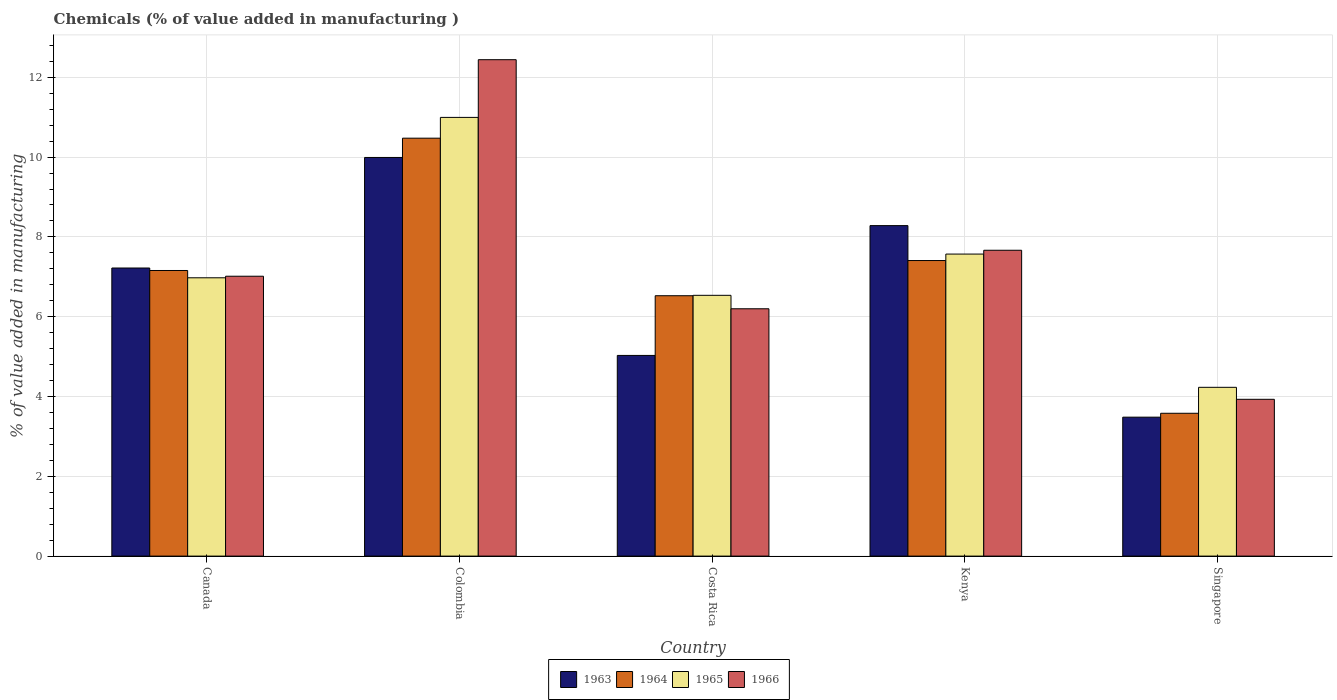How many groups of bars are there?
Make the answer very short. 5. Are the number of bars per tick equal to the number of legend labels?
Provide a succinct answer. Yes. Are the number of bars on each tick of the X-axis equal?
Your response must be concise. Yes. How many bars are there on the 5th tick from the right?
Your answer should be compact. 4. In how many cases, is the number of bars for a given country not equal to the number of legend labels?
Your response must be concise. 0. What is the value added in manufacturing chemicals in 1963 in Canada?
Your answer should be very brief. 7.22. Across all countries, what is the maximum value added in manufacturing chemicals in 1964?
Offer a very short reply. 10.47. Across all countries, what is the minimum value added in manufacturing chemicals in 1965?
Your answer should be compact. 4.23. In which country was the value added in manufacturing chemicals in 1964 minimum?
Your response must be concise. Singapore. What is the total value added in manufacturing chemicals in 1965 in the graph?
Provide a succinct answer. 36.31. What is the difference between the value added in manufacturing chemicals in 1965 in Colombia and that in Costa Rica?
Your answer should be very brief. 4.46. What is the difference between the value added in manufacturing chemicals in 1964 in Canada and the value added in manufacturing chemicals in 1963 in Colombia?
Provide a succinct answer. -2.83. What is the average value added in manufacturing chemicals in 1963 per country?
Provide a short and direct response. 6.8. What is the difference between the value added in manufacturing chemicals of/in 1964 and value added in manufacturing chemicals of/in 1963 in Costa Rica?
Make the answer very short. 1.5. In how many countries, is the value added in manufacturing chemicals in 1965 greater than 7.2 %?
Offer a terse response. 2. What is the ratio of the value added in manufacturing chemicals in 1966 in Canada to that in Kenya?
Your response must be concise. 0.92. Is the difference between the value added in manufacturing chemicals in 1964 in Colombia and Singapore greater than the difference between the value added in manufacturing chemicals in 1963 in Colombia and Singapore?
Make the answer very short. Yes. What is the difference between the highest and the second highest value added in manufacturing chemicals in 1966?
Your response must be concise. -5.43. What is the difference between the highest and the lowest value added in manufacturing chemicals in 1963?
Your answer should be very brief. 6.51. Is the sum of the value added in manufacturing chemicals in 1965 in Canada and Singapore greater than the maximum value added in manufacturing chemicals in 1963 across all countries?
Offer a very short reply. Yes. Is it the case that in every country, the sum of the value added in manufacturing chemicals in 1964 and value added in manufacturing chemicals in 1963 is greater than the sum of value added in manufacturing chemicals in 1965 and value added in manufacturing chemicals in 1966?
Give a very brief answer. No. What does the 4th bar from the left in Kenya represents?
Your response must be concise. 1966. What does the 1st bar from the right in Kenya represents?
Make the answer very short. 1966. Are all the bars in the graph horizontal?
Provide a succinct answer. No. How many countries are there in the graph?
Offer a terse response. 5. What is the difference between two consecutive major ticks on the Y-axis?
Make the answer very short. 2. Are the values on the major ticks of Y-axis written in scientific E-notation?
Make the answer very short. No. Where does the legend appear in the graph?
Ensure brevity in your answer.  Bottom center. How are the legend labels stacked?
Make the answer very short. Horizontal. What is the title of the graph?
Offer a terse response. Chemicals (% of value added in manufacturing ). What is the label or title of the X-axis?
Keep it short and to the point. Country. What is the label or title of the Y-axis?
Ensure brevity in your answer.  % of value added in manufacturing. What is the % of value added in manufacturing of 1963 in Canada?
Ensure brevity in your answer.  7.22. What is the % of value added in manufacturing in 1964 in Canada?
Your response must be concise. 7.16. What is the % of value added in manufacturing of 1965 in Canada?
Provide a short and direct response. 6.98. What is the % of value added in manufacturing in 1966 in Canada?
Provide a succinct answer. 7.01. What is the % of value added in manufacturing of 1963 in Colombia?
Your response must be concise. 9.99. What is the % of value added in manufacturing of 1964 in Colombia?
Make the answer very short. 10.47. What is the % of value added in manufacturing of 1965 in Colombia?
Make the answer very short. 10.99. What is the % of value added in manufacturing in 1966 in Colombia?
Provide a short and direct response. 12.44. What is the % of value added in manufacturing in 1963 in Costa Rica?
Your answer should be very brief. 5.03. What is the % of value added in manufacturing of 1964 in Costa Rica?
Your response must be concise. 6.53. What is the % of value added in manufacturing of 1965 in Costa Rica?
Your answer should be very brief. 6.54. What is the % of value added in manufacturing in 1966 in Costa Rica?
Offer a terse response. 6.2. What is the % of value added in manufacturing in 1963 in Kenya?
Offer a terse response. 8.28. What is the % of value added in manufacturing of 1964 in Kenya?
Your response must be concise. 7.41. What is the % of value added in manufacturing of 1965 in Kenya?
Provide a short and direct response. 7.57. What is the % of value added in manufacturing of 1966 in Kenya?
Provide a short and direct response. 7.67. What is the % of value added in manufacturing in 1963 in Singapore?
Provide a short and direct response. 3.48. What is the % of value added in manufacturing of 1964 in Singapore?
Offer a very short reply. 3.58. What is the % of value added in manufacturing in 1965 in Singapore?
Make the answer very short. 4.23. What is the % of value added in manufacturing of 1966 in Singapore?
Your answer should be compact. 3.93. Across all countries, what is the maximum % of value added in manufacturing in 1963?
Keep it short and to the point. 9.99. Across all countries, what is the maximum % of value added in manufacturing of 1964?
Make the answer very short. 10.47. Across all countries, what is the maximum % of value added in manufacturing of 1965?
Make the answer very short. 10.99. Across all countries, what is the maximum % of value added in manufacturing in 1966?
Offer a very short reply. 12.44. Across all countries, what is the minimum % of value added in manufacturing in 1963?
Provide a short and direct response. 3.48. Across all countries, what is the minimum % of value added in manufacturing in 1964?
Keep it short and to the point. 3.58. Across all countries, what is the minimum % of value added in manufacturing of 1965?
Your response must be concise. 4.23. Across all countries, what is the minimum % of value added in manufacturing of 1966?
Ensure brevity in your answer.  3.93. What is the total % of value added in manufacturing in 1963 in the graph?
Your answer should be very brief. 34.01. What is the total % of value added in manufacturing of 1964 in the graph?
Offer a very short reply. 35.15. What is the total % of value added in manufacturing in 1965 in the graph?
Your response must be concise. 36.31. What is the total % of value added in manufacturing of 1966 in the graph?
Your response must be concise. 37.25. What is the difference between the % of value added in manufacturing of 1963 in Canada and that in Colombia?
Offer a very short reply. -2.77. What is the difference between the % of value added in manufacturing of 1964 in Canada and that in Colombia?
Offer a terse response. -3.32. What is the difference between the % of value added in manufacturing of 1965 in Canada and that in Colombia?
Keep it short and to the point. -4.02. What is the difference between the % of value added in manufacturing of 1966 in Canada and that in Colombia?
Give a very brief answer. -5.43. What is the difference between the % of value added in manufacturing of 1963 in Canada and that in Costa Rica?
Give a very brief answer. 2.19. What is the difference between the % of value added in manufacturing in 1964 in Canada and that in Costa Rica?
Your response must be concise. 0.63. What is the difference between the % of value added in manufacturing in 1965 in Canada and that in Costa Rica?
Your response must be concise. 0.44. What is the difference between the % of value added in manufacturing of 1966 in Canada and that in Costa Rica?
Give a very brief answer. 0.82. What is the difference between the % of value added in manufacturing of 1963 in Canada and that in Kenya?
Your response must be concise. -1.06. What is the difference between the % of value added in manufacturing in 1964 in Canada and that in Kenya?
Your answer should be very brief. -0.25. What is the difference between the % of value added in manufacturing of 1965 in Canada and that in Kenya?
Your answer should be very brief. -0.59. What is the difference between the % of value added in manufacturing in 1966 in Canada and that in Kenya?
Provide a succinct answer. -0.65. What is the difference between the % of value added in manufacturing in 1963 in Canada and that in Singapore?
Your answer should be compact. 3.74. What is the difference between the % of value added in manufacturing of 1964 in Canada and that in Singapore?
Keep it short and to the point. 3.58. What is the difference between the % of value added in manufacturing in 1965 in Canada and that in Singapore?
Your answer should be very brief. 2.75. What is the difference between the % of value added in manufacturing of 1966 in Canada and that in Singapore?
Provide a short and direct response. 3.08. What is the difference between the % of value added in manufacturing in 1963 in Colombia and that in Costa Rica?
Keep it short and to the point. 4.96. What is the difference between the % of value added in manufacturing of 1964 in Colombia and that in Costa Rica?
Your response must be concise. 3.95. What is the difference between the % of value added in manufacturing in 1965 in Colombia and that in Costa Rica?
Your response must be concise. 4.46. What is the difference between the % of value added in manufacturing of 1966 in Colombia and that in Costa Rica?
Provide a short and direct response. 6.24. What is the difference between the % of value added in manufacturing of 1963 in Colombia and that in Kenya?
Your response must be concise. 1.71. What is the difference between the % of value added in manufacturing in 1964 in Colombia and that in Kenya?
Provide a succinct answer. 3.07. What is the difference between the % of value added in manufacturing of 1965 in Colombia and that in Kenya?
Ensure brevity in your answer.  3.43. What is the difference between the % of value added in manufacturing of 1966 in Colombia and that in Kenya?
Make the answer very short. 4.78. What is the difference between the % of value added in manufacturing in 1963 in Colombia and that in Singapore?
Give a very brief answer. 6.51. What is the difference between the % of value added in manufacturing of 1964 in Colombia and that in Singapore?
Offer a very short reply. 6.89. What is the difference between the % of value added in manufacturing in 1965 in Colombia and that in Singapore?
Keep it short and to the point. 6.76. What is the difference between the % of value added in manufacturing in 1966 in Colombia and that in Singapore?
Offer a very short reply. 8.51. What is the difference between the % of value added in manufacturing of 1963 in Costa Rica and that in Kenya?
Your answer should be very brief. -3.25. What is the difference between the % of value added in manufacturing of 1964 in Costa Rica and that in Kenya?
Your answer should be very brief. -0.88. What is the difference between the % of value added in manufacturing in 1965 in Costa Rica and that in Kenya?
Ensure brevity in your answer.  -1.03. What is the difference between the % of value added in manufacturing in 1966 in Costa Rica and that in Kenya?
Your answer should be very brief. -1.47. What is the difference between the % of value added in manufacturing in 1963 in Costa Rica and that in Singapore?
Provide a succinct answer. 1.55. What is the difference between the % of value added in manufacturing in 1964 in Costa Rica and that in Singapore?
Provide a short and direct response. 2.95. What is the difference between the % of value added in manufacturing of 1965 in Costa Rica and that in Singapore?
Provide a succinct answer. 2.31. What is the difference between the % of value added in manufacturing of 1966 in Costa Rica and that in Singapore?
Your response must be concise. 2.27. What is the difference between the % of value added in manufacturing in 1963 in Kenya and that in Singapore?
Your answer should be very brief. 4.8. What is the difference between the % of value added in manufacturing in 1964 in Kenya and that in Singapore?
Offer a terse response. 3.83. What is the difference between the % of value added in manufacturing of 1965 in Kenya and that in Singapore?
Give a very brief answer. 3.34. What is the difference between the % of value added in manufacturing in 1966 in Kenya and that in Singapore?
Provide a succinct answer. 3.74. What is the difference between the % of value added in manufacturing in 1963 in Canada and the % of value added in manufacturing in 1964 in Colombia?
Your response must be concise. -3.25. What is the difference between the % of value added in manufacturing of 1963 in Canada and the % of value added in manufacturing of 1965 in Colombia?
Give a very brief answer. -3.77. What is the difference between the % of value added in manufacturing in 1963 in Canada and the % of value added in manufacturing in 1966 in Colombia?
Make the answer very short. -5.22. What is the difference between the % of value added in manufacturing of 1964 in Canada and the % of value added in manufacturing of 1965 in Colombia?
Ensure brevity in your answer.  -3.84. What is the difference between the % of value added in manufacturing of 1964 in Canada and the % of value added in manufacturing of 1966 in Colombia?
Your answer should be very brief. -5.28. What is the difference between the % of value added in manufacturing of 1965 in Canada and the % of value added in manufacturing of 1966 in Colombia?
Your answer should be compact. -5.47. What is the difference between the % of value added in manufacturing of 1963 in Canada and the % of value added in manufacturing of 1964 in Costa Rica?
Your answer should be compact. 0.69. What is the difference between the % of value added in manufacturing of 1963 in Canada and the % of value added in manufacturing of 1965 in Costa Rica?
Offer a terse response. 0.68. What is the difference between the % of value added in manufacturing in 1963 in Canada and the % of value added in manufacturing in 1966 in Costa Rica?
Give a very brief answer. 1.02. What is the difference between the % of value added in manufacturing of 1964 in Canada and the % of value added in manufacturing of 1965 in Costa Rica?
Provide a succinct answer. 0.62. What is the difference between the % of value added in manufacturing of 1964 in Canada and the % of value added in manufacturing of 1966 in Costa Rica?
Make the answer very short. 0.96. What is the difference between the % of value added in manufacturing of 1965 in Canada and the % of value added in manufacturing of 1966 in Costa Rica?
Offer a terse response. 0.78. What is the difference between the % of value added in manufacturing in 1963 in Canada and the % of value added in manufacturing in 1964 in Kenya?
Offer a terse response. -0.19. What is the difference between the % of value added in manufacturing in 1963 in Canada and the % of value added in manufacturing in 1965 in Kenya?
Your answer should be very brief. -0.35. What is the difference between the % of value added in manufacturing in 1963 in Canada and the % of value added in manufacturing in 1966 in Kenya?
Keep it short and to the point. -0.44. What is the difference between the % of value added in manufacturing in 1964 in Canada and the % of value added in manufacturing in 1965 in Kenya?
Give a very brief answer. -0.41. What is the difference between the % of value added in manufacturing of 1964 in Canada and the % of value added in manufacturing of 1966 in Kenya?
Provide a short and direct response. -0.51. What is the difference between the % of value added in manufacturing of 1965 in Canada and the % of value added in manufacturing of 1966 in Kenya?
Offer a terse response. -0.69. What is the difference between the % of value added in manufacturing of 1963 in Canada and the % of value added in manufacturing of 1964 in Singapore?
Keep it short and to the point. 3.64. What is the difference between the % of value added in manufacturing in 1963 in Canada and the % of value added in manufacturing in 1965 in Singapore?
Keep it short and to the point. 2.99. What is the difference between the % of value added in manufacturing of 1963 in Canada and the % of value added in manufacturing of 1966 in Singapore?
Offer a very short reply. 3.29. What is the difference between the % of value added in manufacturing of 1964 in Canada and the % of value added in manufacturing of 1965 in Singapore?
Your answer should be compact. 2.93. What is the difference between the % of value added in manufacturing of 1964 in Canada and the % of value added in manufacturing of 1966 in Singapore?
Give a very brief answer. 3.23. What is the difference between the % of value added in manufacturing of 1965 in Canada and the % of value added in manufacturing of 1966 in Singapore?
Provide a short and direct response. 3.05. What is the difference between the % of value added in manufacturing in 1963 in Colombia and the % of value added in manufacturing in 1964 in Costa Rica?
Make the answer very short. 3.47. What is the difference between the % of value added in manufacturing of 1963 in Colombia and the % of value added in manufacturing of 1965 in Costa Rica?
Your answer should be very brief. 3.46. What is the difference between the % of value added in manufacturing of 1963 in Colombia and the % of value added in manufacturing of 1966 in Costa Rica?
Your answer should be compact. 3.79. What is the difference between the % of value added in manufacturing of 1964 in Colombia and the % of value added in manufacturing of 1965 in Costa Rica?
Ensure brevity in your answer.  3.94. What is the difference between the % of value added in manufacturing in 1964 in Colombia and the % of value added in manufacturing in 1966 in Costa Rica?
Give a very brief answer. 4.28. What is the difference between the % of value added in manufacturing in 1965 in Colombia and the % of value added in manufacturing in 1966 in Costa Rica?
Provide a short and direct response. 4.8. What is the difference between the % of value added in manufacturing of 1963 in Colombia and the % of value added in manufacturing of 1964 in Kenya?
Your answer should be very brief. 2.58. What is the difference between the % of value added in manufacturing in 1963 in Colombia and the % of value added in manufacturing in 1965 in Kenya?
Ensure brevity in your answer.  2.42. What is the difference between the % of value added in manufacturing in 1963 in Colombia and the % of value added in manufacturing in 1966 in Kenya?
Make the answer very short. 2.33. What is the difference between the % of value added in manufacturing of 1964 in Colombia and the % of value added in manufacturing of 1965 in Kenya?
Keep it short and to the point. 2.9. What is the difference between the % of value added in manufacturing of 1964 in Colombia and the % of value added in manufacturing of 1966 in Kenya?
Provide a succinct answer. 2.81. What is the difference between the % of value added in manufacturing of 1965 in Colombia and the % of value added in manufacturing of 1966 in Kenya?
Provide a succinct answer. 3.33. What is the difference between the % of value added in manufacturing of 1963 in Colombia and the % of value added in manufacturing of 1964 in Singapore?
Make the answer very short. 6.41. What is the difference between the % of value added in manufacturing of 1963 in Colombia and the % of value added in manufacturing of 1965 in Singapore?
Make the answer very short. 5.76. What is the difference between the % of value added in manufacturing in 1963 in Colombia and the % of value added in manufacturing in 1966 in Singapore?
Give a very brief answer. 6.06. What is the difference between the % of value added in manufacturing in 1964 in Colombia and the % of value added in manufacturing in 1965 in Singapore?
Make the answer very short. 6.24. What is the difference between the % of value added in manufacturing in 1964 in Colombia and the % of value added in manufacturing in 1966 in Singapore?
Keep it short and to the point. 6.54. What is the difference between the % of value added in manufacturing of 1965 in Colombia and the % of value added in manufacturing of 1966 in Singapore?
Keep it short and to the point. 7.07. What is the difference between the % of value added in manufacturing in 1963 in Costa Rica and the % of value added in manufacturing in 1964 in Kenya?
Your answer should be very brief. -2.38. What is the difference between the % of value added in manufacturing of 1963 in Costa Rica and the % of value added in manufacturing of 1965 in Kenya?
Ensure brevity in your answer.  -2.54. What is the difference between the % of value added in manufacturing in 1963 in Costa Rica and the % of value added in manufacturing in 1966 in Kenya?
Offer a terse response. -2.64. What is the difference between the % of value added in manufacturing in 1964 in Costa Rica and the % of value added in manufacturing in 1965 in Kenya?
Provide a short and direct response. -1.04. What is the difference between the % of value added in manufacturing of 1964 in Costa Rica and the % of value added in manufacturing of 1966 in Kenya?
Provide a short and direct response. -1.14. What is the difference between the % of value added in manufacturing of 1965 in Costa Rica and the % of value added in manufacturing of 1966 in Kenya?
Provide a short and direct response. -1.13. What is the difference between the % of value added in manufacturing in 1963 in Costa Rica and the % of value added in manufacturing in 1964 in Singapore?
Provide a short and direct response. 1.45. What is the difference between the % of value added in manufacturing in 1963 in Costa Rica and the % of value added in manufacturing in 1965 in Singapore?
Give a very brief answer. 0.8. What is the difference between the % of value added in manufacturing of 1963 in Costa Rica and the % of value added in manufacturing of 1966 in Singapore?
Keep it short and to the point. 1.1. What is the difference between the % of value added in manufacturing in 1964 in Costa Rica and the % of value added in manufacturing in 1965 in Singapore?
Make the answer very short. 2.3. What is the difference between the % of value added in manufacturing in 1964 in Costa Rica and the % of value added in manufacturing in 1966 in Singapore?
Your response must be concise. 2.6. What is the difference between the % of value added in manufacturing in 1965 in Costa Rica and the % of value added in manufacturing in 1966 in Singapore?
Offer a terse response. 2.61. What is the difference between the % of value added in manufacturing in 1963 in Kenya and the % of value added in manufacturing in 1964 in Singapore?
Ensure brevity in your answer.  4.7. What is the difference between the % of value added in manufacturing of 1963 in Kenya and the % of value added in manufacturing of 1965 in Singapore?
Your answer should be very brief. 4.05. What is the difference between the % of value added in manufacturing of 1963 in Kenya and the % of value added in manufacturing of 1966 in Singapore?
Your answer should be very brief. 4.35. What is the difference between the % of value added in manufacturing of 1964 in Kenya and the % of value added in manufacturing of 1965 in Singapore?
Your response must be concise. 3.18. What is the difference between the % of value added in manufacturing of 1964 in Kenya and the % of value added in manufacturing of 1966 in Singapore?
Offer a terse response. 3.48. What is the difference between the % of value added in manufacturing of 1965 in Kenya and the % of value added in manufacturing of 1966 in Singapore?
Offer a very short reply. 3.64. What is the average % of value added in manufacturing in 1963 per country?
Make the answer very short. 6.8. What is the average % of value added in manufacturing of 1964 per country?
Provide a short and direct response. 7.03. What is the average % of value added in manufacturing of 1965 per country?
Ensure brevity in your answer.  7.26. What is the average % of value added in manufacturing in 1966 per country?
Your answer should be very brief. 7.45. What is the difference between the % of value added in manufacturing in 1963 and % of value added in manufacturing in 1964 in Canada?
Offer a terse response. 0.06. What is the difference between the % of value added in manufacturing in 1963 and % of value added in manufacturing in 1965 in Canada?
Provide a short and direct response. 0.25. What is the difference between the % of value added in manufacturing in 1963 and % of value added in manufacturing in 1966 in Canada?
Ensure brevity in your answer.  0.21. What is the difference between the % of value added in manufacturing in 1964 and % of value added in manufacturing in 1965 in Canada?
Your answer should be very brief. 0.18. What is the difference between the % of value added in manufacturing in 1964 and % of value added in manufacturing in 1966 in Canada?
Provide a succinct answer. 0.14. What is the difference between the % of value added in manufacturing of 1965 and % of value added in manufacturing of 1966 in Canada?
Your response must be concise. -0.04. What is the difference between the % of value added in manufacturing in 1963 and % of value added in manufacturing in 1964 in Colombia?
Provide a succinct answer. -0.48. What is the difference between the % of value added in manufacturing in 1963 and % of value added in manufacturing in 1965 in Colombia?
Your answer should be compact. -1. What is the difference between the % of value added in manufacturing of 1963 and % of value added in manufacturing of 1966 in Colombia?
Make the answer very short. -2.45. What is the difference between the % of value added in manufacturing in 1964 and % of value added in manufacturing in 1965 in Colombia?
Keep it short and to the point. -0.52. What is the difference between the % of value added in manufacturing in 1964 and % of value added in manufacturing in 1966 in Colombia?
Your answer should be very brief. -1.97. What is the difference between the % of value added in manufacturing in 1965 and % of value added in manufacturing in 1966 in Colombia?
Your response must be concise. -1.45. What is the difference between the % of value added in manufacturing of 1963 and % of value added in manufacturing of 1964 in Costa Rica?
Give a very brief answer. -1.5. What is the difference between the % of value added in manufacturing of 1963 and % of value added in manufacturing of 1965 in Costa Rica?
Your answer should be compact. -1.51. What is the difference between the % of value added in manufacturing in 1963 and % of value added in manufacturing in 1966 in Costa Rica?
Offer a very short reply. -1.17. What is the difference between the % of value added in manufacturing in 1964 and % of value added in manufacturing in 1965 in Costa Rica?
Keep it short and to the point. -0.01. What is the difference between the % of value added in manufacturing in 1964 and % of value added in manufacturing in 1966 in Costa Rica?
Keep it short and to the point. 0.33. What is the difference between the % of value added in manufacturing in 1965 and % of value added in manufacturing in 1966 in Costa Rica?
Provide a short and direct response. 0.34. What is the difference between the % of value added in manufacturing of 1963 and % of value added in manufacturing of 1964 in Kenya?
Your answer should be very brief. 0.87. What is the difference between the % of value added in manufacturing of 1963 and % of value added in manufacturing of 1965 in Kenya?
Provide a succinct answer. 0.71. What is the difference between the % of value added in manufacturing of 1963 and % of value added in manufacturing of 1966 in Kenya?
Give a very brief answer. 0.62. What is the difference between the % of value added in manufacturing of 1964 and % of value added in manufacturing of 1965 in Kenya?
Your answer should be compact. -0.16. What is the difference between the % of value added in manufacturing in 1964 and % of value added in manufacturing in 1966 in Kenya?
Provide a succinct answer. -0.26. What is the difference between the % of value added in manufacturing in 1965 and % of value added in manufacturing in 1966 in Kenya?
Provide a succinct answer. -0.1. What is the difference between the % of value added in manufacturing of 1963 and % of value added in manufacturing of 1964 in Singapore?
Provide a short and direct response. -0.1. What is the difference between the % of value added in manufacturing of 1963 and % of value added in manufacturing of 1965 in Singapore?
Your answer should be very brief. -0.75. What is the difference between the % of value added in manufacturing of 1963 and % of value added in manufacturing of 1966 in Singapore?
Keep it short and to the point. -0.45. What is the difference between the % of value added in manufacturing in 1964 and % of value added in manufacturing in 1965 in Singapore?
Your answer should be very brief. -0.65. What is the difference between the % of value added in manufacturing of 1964 and % of value added in manufacturing of 1966 in Singapore?
Your answer should be very brief. -0.35. What is the difference between the % of value added in manufacturing in 1965 and % of value added in manufacturing in 1966 in Singapore?
Make the answer very short. 0.3. What is the ratio of the % of value added in manufacturing of 1963 in Canada to that in Colombia?
Provide a succinct answer. 0.72. What is the ratio of the % of value added in manufacturing of 1964 in Canada to that in Colombia?
Offer a very short reply. 0.68. What is the ratio of the % of value added in manufacturing in 1965 in Canada to that in Colombia?
Give a very brief answer. 0.63. What is the ratio of the % of value added in manufacturing in 1966 in Canada to that in Colombia?
Keep it short and to the point. 0.56. What is the ratio of the % of value added in manufacturing of 1963 in Canada to that in Costa Rica?
Your response must be concise. 1.44. What is the ratio of the % of value added in manufacturing in 1964 in Canada to that in Costa Rica?
Offer a very short reply. 1.1. What is the ratio of the % of value added in manufacturing in 1965 in Canada to that in Costa Rica?
Offer a very short reply. 1.07. What is the ratio of the % of value added in manufacturing in 1966 in Canada to that in Costa Rica?
Keep it short and to the point. 1.13. What is the ratio of the % of value added in manufacturing of 1963 in Canada to that in Kenya?
Provide a short and direct response. 0.87. What is the ratio of the % of value added in manufacturing of 1964 in Canada to that in Kenya?
Provide a succinct answer. 0.97. What is the ratio of the % of value added in manufacturing of 1965 in Canada to that in Kenya?
Make the answer very short. 0.92. What is the ratio of the % of value added in manufacturing in 1966 in Canada to that in Kenya?
Your answer should be compact. 0.92. What is the ratio of the % of value added in manufacturing in 1963 in Canada to that in Singapore?
Make the answer very short. 2.07. What is the ratio of the % of value added in manufacturing in 1964 in Canada to that in Singapore?
Provide a succinct answer. 2. What is the ratio of the % of value added in manufacturing in 1965 in Canada to that in Singapore?
Keep it short and to the point. 1.65. What is the ratio of the % of value added in manufacturing in 1966 in Canada to that in Singapore?
Provide a succinct answer. 1.78. What is the ratio of the % of value added in manufacturing of 1963 in Colombia to that in Costa Rica?
Ensure brevity in your answer.  1.99. What is the ratio of the % of value added in manufacturing of 1964 in Colombia to that in Costa Rica?
Offer a very short reply. 1.61. What is the ratio of the % of value added in manufacturing of 1965 in Colombia to that in Costa Rica?
Offer a very short reply. 1.68. What is the ratio of the % of value added in manufacturing in 1966 in Colombia to that in Costa Rica?
Provide a succinct answer. 2.01. What is the ratio of the % of value added in manufacturing of 1963 in Colombia to that in Kenya?
Offer a terse response. 1.21. What is the ratio of the % of value added in manufacturing of 1964 in Colombia to that in Kenya?
Offer a very short reply. 1.41. What is the ratio of the % of value added in manufacturing of 1965 in Colombia to that in Kenya?
Ensure brevity in your answer.  1.45. What is the ratio of the % of value added in manufacturing of 1966 in Colombia to that in Kenya?
Ensure brevity in your answer.  1.62. What is the ratio of the % of value added in manufacturing in 1963 in Colombia to that in Singapore?
Offer a terse response. 2.87. What is the ratio of the % of value added in manufacturing of 1964 in Colombia to that in Singapore?
Keep it short and to the point. 2.93. What is the ratio of the % of value added in manufacturing of 1965 in Colombia to that in Singapore?
Provide a short and direct response. 2.6. What is the ratio of the % of value added in manufacturing of 1966 in Colombia to that in Singapore?
Give a very brief answer. 3.17. What is the ratio of the % of value added in manufacturing of 1963 in Costa Rica to that in Kenya?
Your answer should be very brief. 0.61. What is the ratio of the % of value added in manufacturing of 1964 in Costa Rica to that in Kenya?
Keep it short and to the point. 0.88. What is the ratio of the % of value added in manufacturing of 1965 in Costa Rica to that in Kenya?
Your answer should be very brief. 0.86. What is the ratio of the % of value added in manufacturing of 1966 in Costa Rica to that in Kenya?
Provide a short and direct response. 0.81. What is the ratio of the % of value added in manufacturing in 1963 in Costa Rica to that in Singapore?
Give a very brief answer. 1.44. What is the ratio of the % of value added in manufacturing of 1964 in Costa Rica to that in Singapore?
Provide a short and direct response. 1.82. What is the ratio of the % of value added in manufacturing of 1965 in Costa Rica to that in Singapore?
Your answer should be compact. 1.55. What is the ratio of the % of value added in manufacturing in 1966 in Costa Rica to that in Singapore?
Make the answer very short. 1.58. What is the ratio of the % of value added in manufacturing of 1963 in Kenya to that in Singapore?
Make the answer very short. 2.38. What is the ratio of the % of value added in manufacturing of 1964 in Kenya to that in Singapore?
Provide a succinct answer. 2.07. What is the ratio of the % of value added in manufacturing of 1965 in Kenya to that in Singapore?
Your answer should be very brief. 1.79. What is the ratio of the % of value added in manufacturing of 1966 in Kenya to that in Singapore?
Your response must be concise. 1.95. What is the difference between the highest and the second highest % of value added in manufacturing in 1963?
Your answer should be very brief. 1.71. What is the difference between the highest and the second highest % of value added in manufacturing in 1964?
Offer a very short reply. 3.07. What is the difference between the highest and the second highest % of value added in manufacturing of 1965?
Give a very brief answer. 3.43. What is the difference between the highest and the second highest % of value added in manufacturing in 1966?
Your answer should be very brief. 4.78. What is the difference between the highest and the lowest % of value added in manufacturing of 1963?
Your answer should be very brief. 6.51. What is the difference between the highest and the lowest % of value added in manufacturing of 1964?
Give a very brief answer. 6.89. What is the difference between the highest and the lowest % of value added in manufacturing in 1965?
Keep it short and to the point. 6.76. What is the difference between the highest and the lowest % of value added in manufacturing in 1966?
Provide a succinct answer. 8.51. 